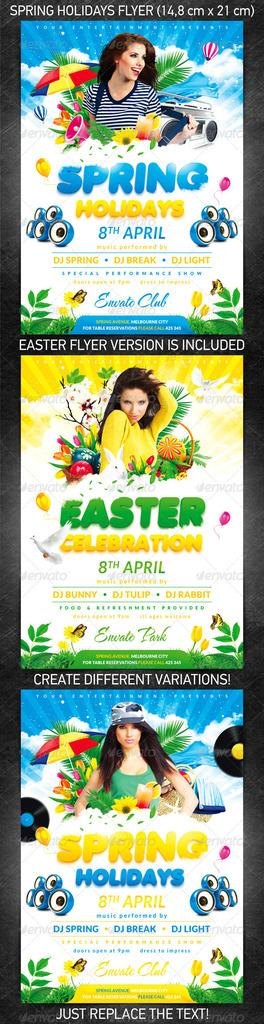<image>
Relay a brief, clear account of the picture shown. Three colorful flyer examples for an Easter celebration. 